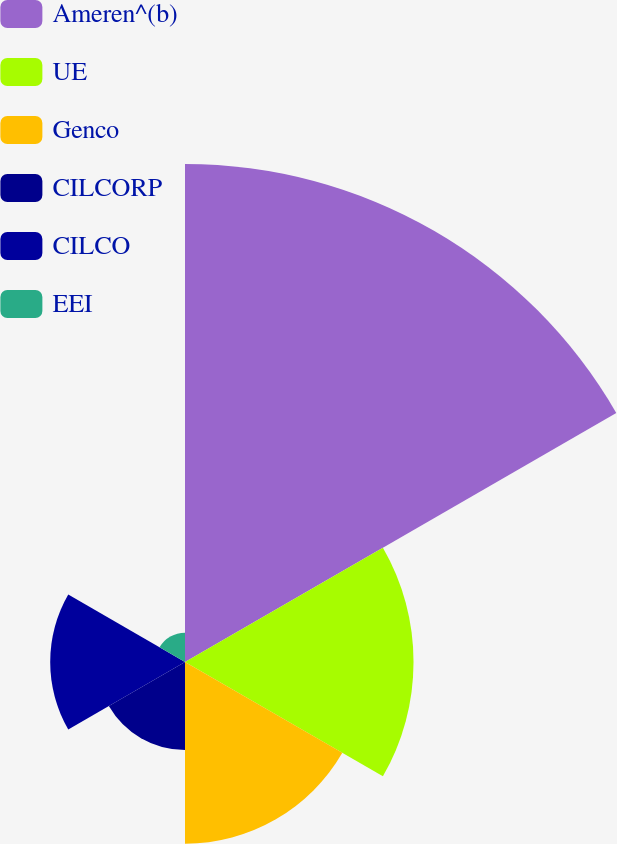Convert chart. <chart><loc_0><loc_0><loc_500><loc_500><pie_chart><fcel>Ameren^(b)<fcel>UE<fcel>Genco<fcel>CILCORP<fcel>CILCO<fcel>EEI<nl><fcel>42.93%<fcel>19.7%<fcel>15.66%<fcel>7.58%<fcel>11.62%<fcel>2.53%<nl></chart> 